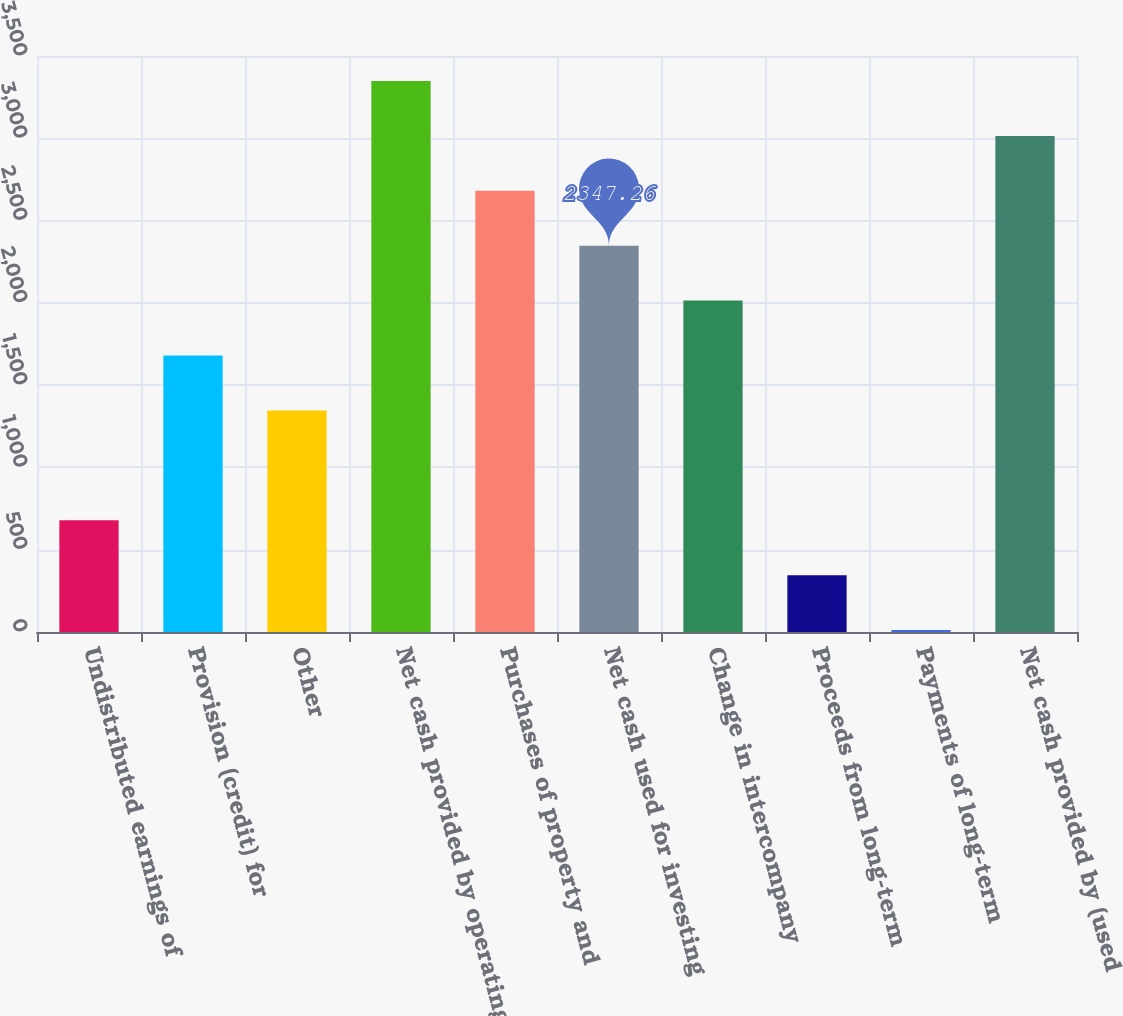Convert chart. <chart><loc_0><loc_0><loc_500><loc_500><bar_chart><fcel>Undistributed earnings of<fcel>Provision (credit) for<fcel>Other<fcel>Net cash provided by operating<fcel>Purchases of property and<fcel>Net cash used for investing<fcel>Change in intercompany<fcel>Proceeds from long-term<fcel>Payments of long-term<fcel>Net cash provided by (used<nl><fcel>678.86<fcel>1679.9<fcel>1346.22<fcel>3348.3<fcel>2680.94<fcel>2347.26<fcel>2013.58<fcel>345.18<fcel>11.5<fcel>3014.62<nl></chart> 